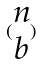Convert formula to latex. <formula><loc_0><loc_0><loc_500><loc_500>( \begin{matrix} n \\ b \end{matrix} )</formula> 